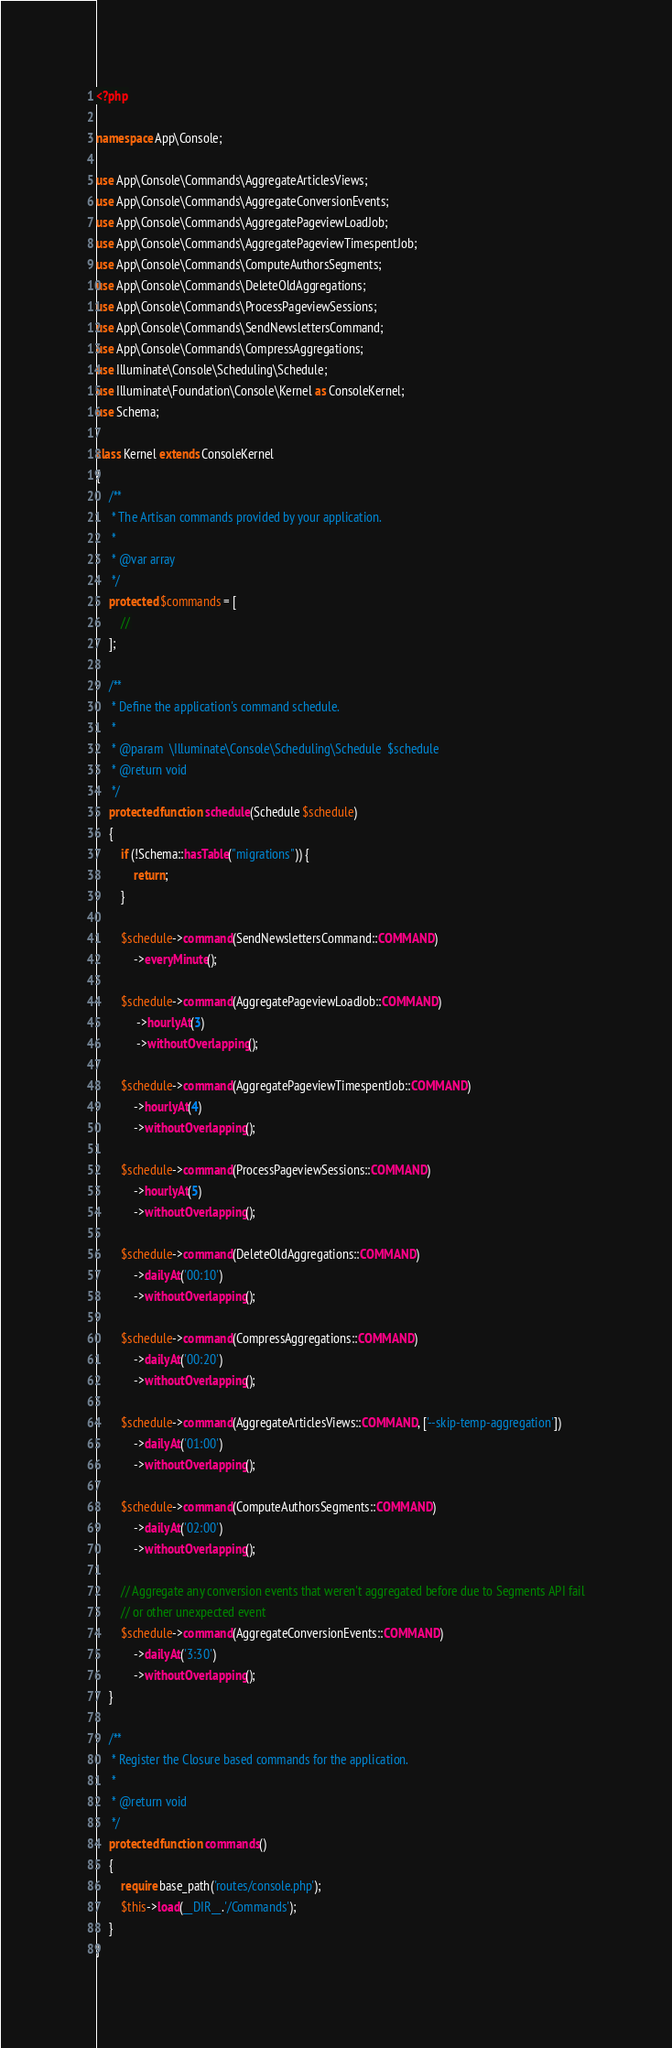<code> <loc_0><loc_0><loc_500><loc_500><_PHP_><?php

namespace App\Console;

use App\Console\Commands\AggregateArticlesViews;
use App\Console\Commands\AggregateConversionEvents;
use App\Console\Commands\AggregatePageviewLoadJob;
use App\Console\Commands\AggregatePageviewTimespentJob;
use App\Console\Commands\ComputeAuthorsSegments;
use App\Console\Commands\DeleteOldAggregations;
use App\Console\Commands\ProcessPageviewSessions;
use App\Console\Commands\SendNewslettersCommand;
use App\Console\Commands\CompressAggregations;
use Illuminate\Console\Scheduling\Schedule;
use Illuminate\Foundation\Console\Kernel as ConsoleKernel;
use Schema;

class Kernel extends ConsoleKernel
{
    /**
     * The Artisan commands provided by your application.
     *
     * @var array
     */
    protected $commands = [
        //
    ];

    /**
     * Define the application's command schedule.
     *
     * @param  \Illuminate\Console\Scheduling\Schedule  $schedule
     * @return void
     */
    protected function schedule(Schedule $schedule)
    {
        if (!Schema::hasTable("migrations")) {
            return;
        }

        $schedule->command(SendNewslettersCommand::COMMAND)
            ->everyMinute();

        $schedule->command(AggregatePageviewLoadJob::COMMAND)
             ->hourlyAt(3)
             ->withoutOverlapping();

        $schedule->command(AggregatePageviewTimespentJob::COMMAND)
            ->hourlyAt(4)
            ->withoutOverlapping();

        $schedule->command(ProcessPageviewSessions::COMMAND)
            ->hourlyAt(5)
            ->withoutOverlapping();

        $schedule->command(DeleteOldAggregations::COMMAND)
            ->dailyAt('00:10')
            ->withoutOverlapping();

        $schedule->command(CompressAggregations::COMMAND)
            ->dailyAt('00:20')
            ->withoutOverlapping();

        $schedule->command(AggregateArticlesViews::COMMAND, ['--skip-temp-aggregation'])
            ->dailyAt('01:00')
            ->withoutOverlapping();

        $schedule->command(ComputeAuthorsSegments::COMMAND)
            ->dailyAt('02:00')
            ->withoutOverlapping();

        // Aggregate any conversion events that weren't aggregated before due to Segments API fail
        // or other unexpected event
        $schedule->command(AggregateConversionEvents::COMMAND)
            ->dailyAt('3:30')
            ->withoutOverlapping();
    }

    /**
     * Register the Closure based commands for the application.
     *
     * @return void
     */
    protected function commands()
    {
        require base_path('routes/console.php');
        $this->load(__DIR__.'/Commands');
    }
}
</code> 